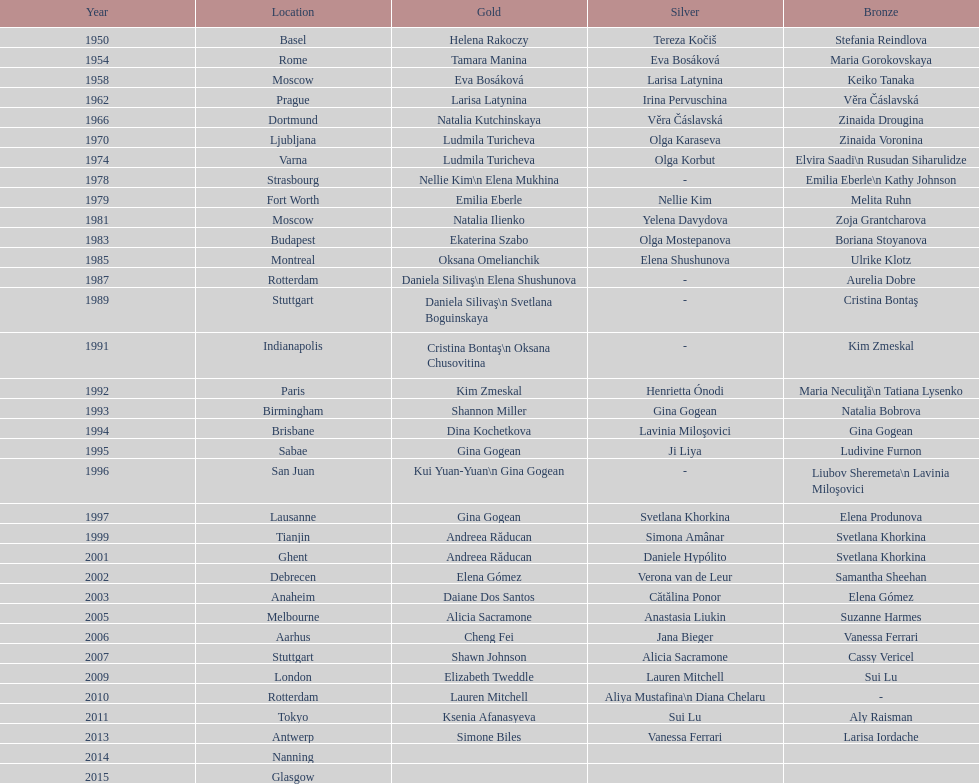Up to 2013, what is the count of gold medals in floor exercise achieved by american women at the world championships? 5. 